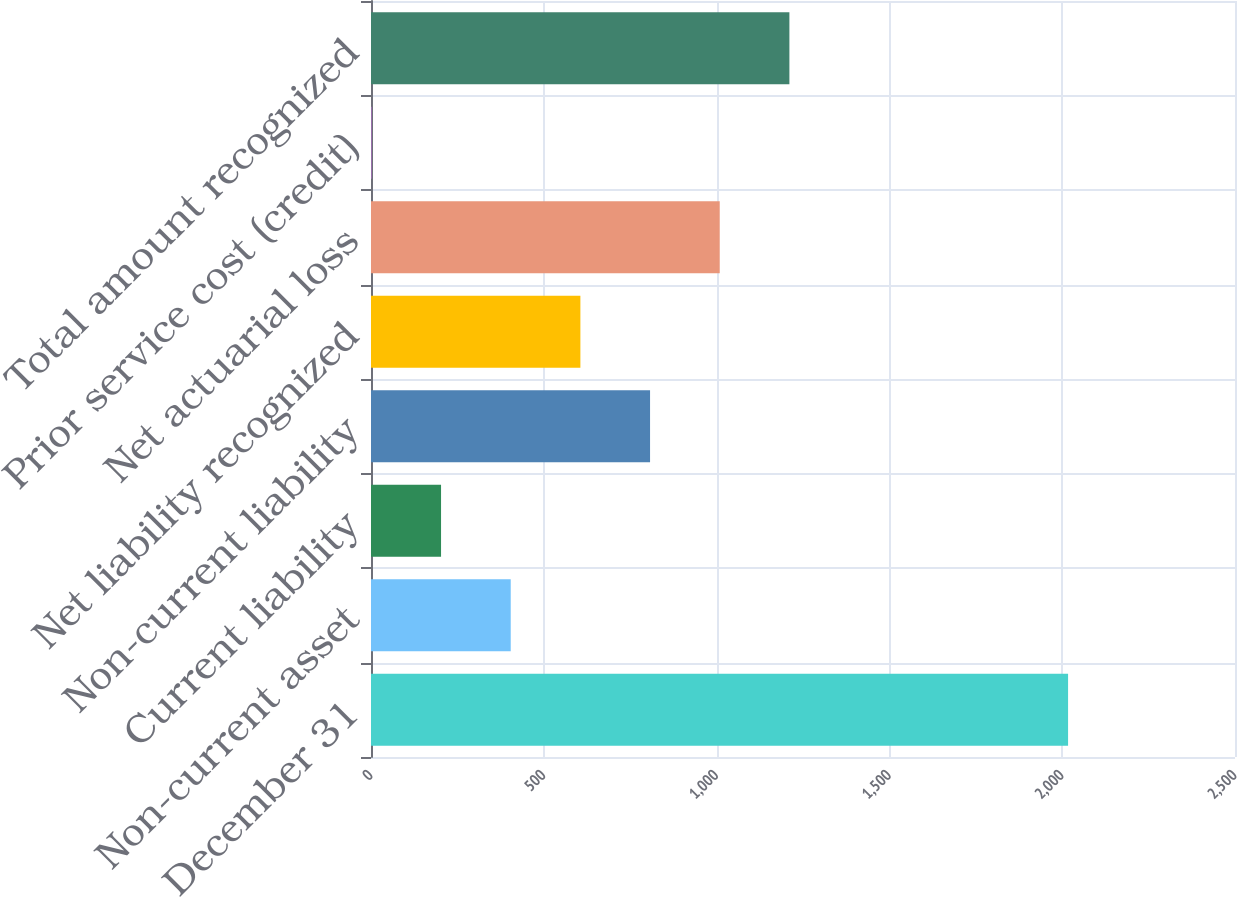Convert chart to OTSL. <chart><loc_0><loc_0><loc_500><loc_500><bar_chart><fcel>December 31<fcel>Non-current asset<fcel>Current liability<fcel>Non-current liability<fcel>Net liability recognized<fcel>Net actuarial loss<fcel>Prior service cost (credit)<fcel>Total amount recognized<nl><fcel>2017<fcel>404.28<fcel>202.69<fcel>807.46<fcel>605.87<fcel>1009.05<fcel>1.1<fcel>1210.64<nl></chart> 